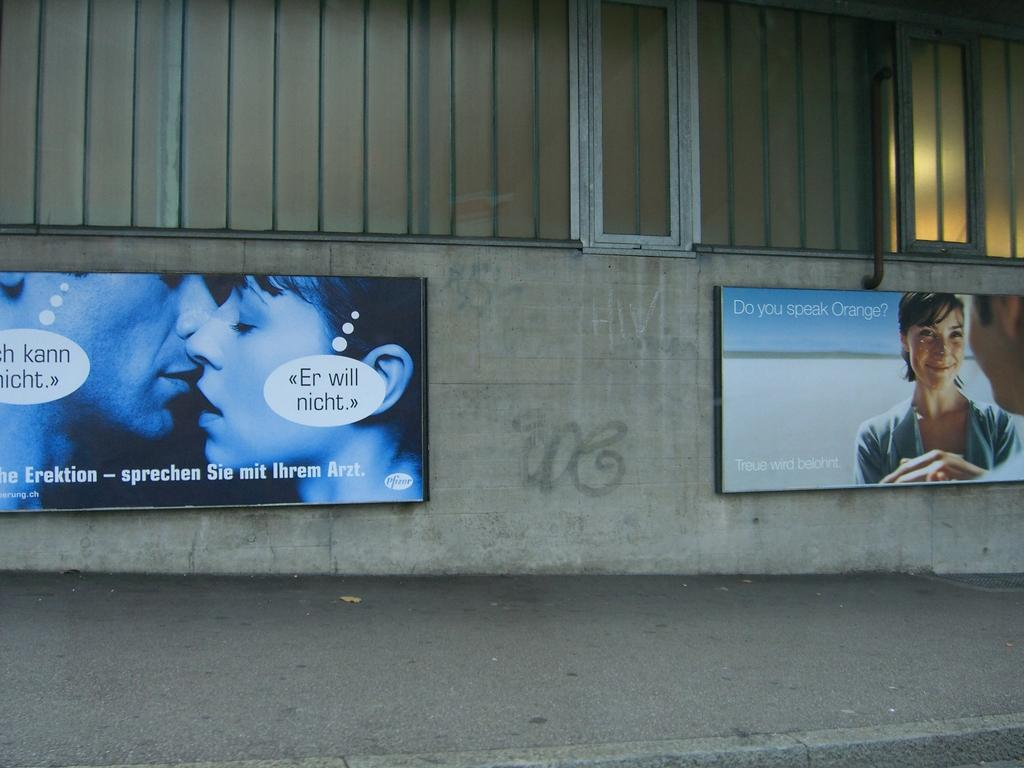What is displayed on the boards in the picture? The boards have text and images in the picture. Where are the boards located? The boards are on a wall. What else can be seen in the image besides the boards? There are windows visible in the image. What type of fire can be seen burning in the image? There is no fire present in the image; it only features boards with text and images on a wall and windows. 